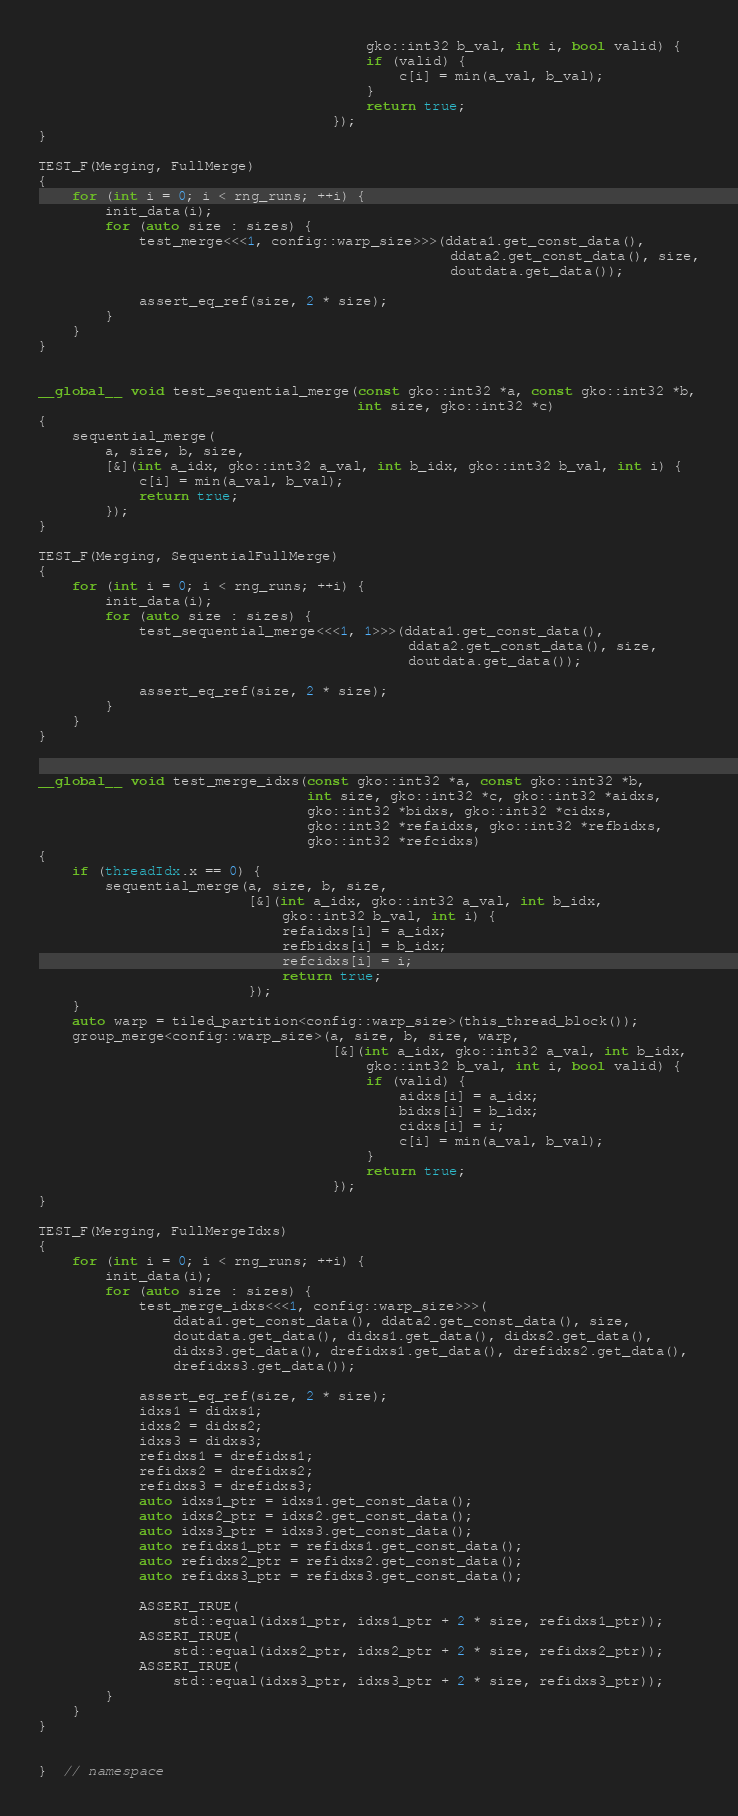Convert code to text. <code><loc_0><loc_0><loc_500><loc_500><_Cuda_>                                       gko::int32 b_val, int i, bool valid) {
                                       if (valid) {
                                           c[i] = min(a_val, b_val);
                                       }
                                       return true;
                                   });
}

TEST_F(Merging, FullMerge)
{
    for (int i = 0; i < rng_runs; ++i) {
        init_data(i);
        for (auto size : sizes) {
            test_merge<<<1, config::warp_size>>>(ddata1.get_const_data(),
                                                 ddata2.get_const_data(), size,
                                                 doutdata.get_data());

            assert_eq_ref(size, 2 * size);
        }
    }
}


__global__ void test_sequential_merge(const gko::int32 *a, const gko::int32 *b,
                                      int size, gko::int32 *c)
{
    sequential_merge(
        a, size, b, size,
        [&](int a_idx, gko::int32 a_val, int b_idx, gko::int32 b_val, int i) {
            c[i] = min(a_val, b_val);
            return true;
        });
}

TEST_F(Merging, SequentialFullMerge)
{
    for (int i = 0; i < rng_runs; ++i) {
        init_data(i);
        for (auto size : sizes) {
            test_sequential_merge<<<1, 1>>>(ddata1.get_const_data(),
                                            ddata2.get_const_data(), size,
                                            doutdata.get_data());

            assert_eq_ref(size, 2 * size);
        }
    }
}


__global__ void test_merge_idxs(const gko::int32 *a, const gko::int32 *b,
                                int size, gko::int32 *c, gko::int32 *aidxs,
                                gko::int32 *bidxs, gko::int32 *cidxs,
                                gko::int32 *refaidxs, gko::int32 *refbidxs,
                                gko::int32 *refcidxs)
{
    if (threadIdx.x == 0) {
        sequential_merge(a, size, b, size,
                         [&](int a_idx, gko::int32 a_val, int b_idx,
                             gko::int32 b_val, int i) {
                             refaidxs[i] = a_idx;
                             refbidxs[i] = b_idx;
                             refcidxs[i] = i;
                             return true;
                         });
    }
    auto warp = tiled_partition<config::warp_size>(this_thread_block());
    group_merge<config::warp_size>(a, size, b, size, warp,
                                   [&](int a_idx, gko::int32 a_val, int b_idx,
                                       gko::int32 b_val, int i, bool valid) {
                                       if (valid) {
                                           aidxs[i] = a_idx;
                                           bidxs[i] = b_idx;
                                           cidxs[i] = i;
                                           c[i] = min(a_val, b_val);
                                       }
                                       return true;
                                   });
}

TEST_F(Merging, FullMergeIdxs)
{
    for (int i = 0; i < rng_runs; ++i) {
        init_data(i);
        for (auto size : sizes) {
            test_merge_idxs<<<1, config::warp_size>>>(
                ddata1.get_const_data(), ddata2.get_const_data(), size,
                doutdata.get_data(), didxs1.get_data(), didxs2.get_data(),
                didxs3.get_data(), drefidxs1.get_data(), drefidxs2.get_data(),
                drefidxs3.get_data());

            assert_eq_ref(size, 2 * size);
            idxs1 = didxs1;
            idxs2 = didxs2;
            idxs3 = didxs3;
            refidxs1 = drefidxs1;
            refidxs2 = drefidxs2;
            refidxs3 = drefidxs3;
            auto idxs1_ptr = idxs1.get_const_data();
            auto idxs2_ptr = idxs2.get_const_data();
            auto idxs3_ptr = idxs3.get_const_data();
            auto refidxs1_ptr = refidxs1.get_const_data();
            auto refidxs2_ptr = refidxs2.get_const_data();
            auto refidxs3_ptr = refidxs3.get_const_data();

            ASSERT_TRUE(
                std::equal(idxs1_ptr, idxs1_ptr + 2 * size, refidxs1_ptr));
            ASSERT_TRUE(
                std::equal(idxs2_ptr, idxs2_ptr + 2 * size, refidxs2_ptr));
            ASSERT_TRUE(
                std::equal(idxs3_ptr, idxs3_ptr + 2 * size, refidxs3_ptr));
        }
    }
}


}  // namespace
</code> 